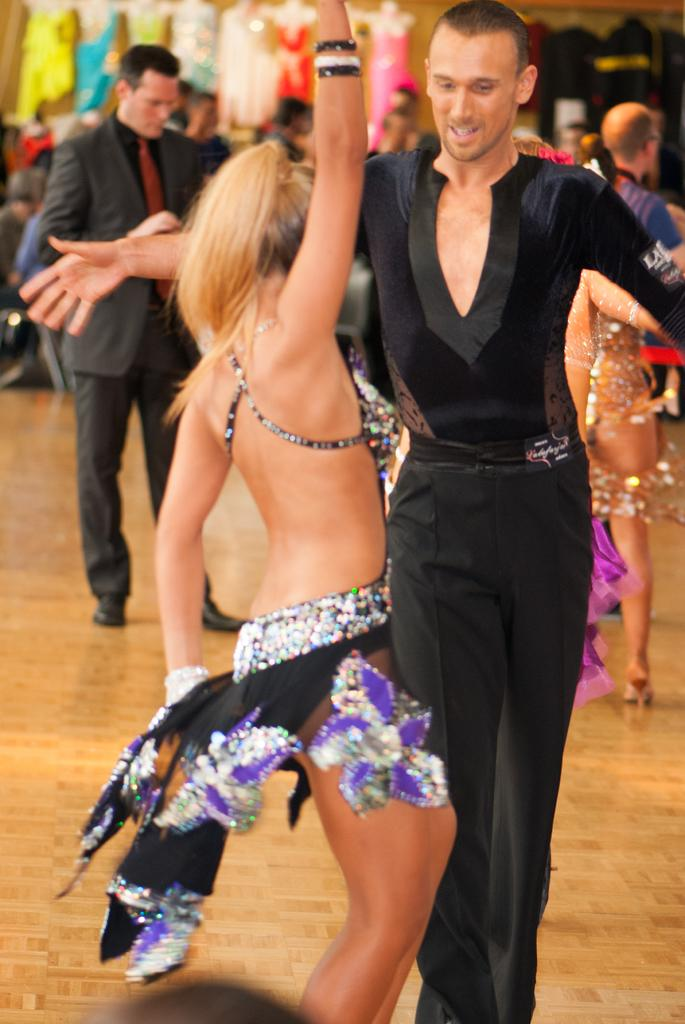Who are the two people in the image? There is a man and a woman in the image. What are they doing in the image? They are dancing on the floor. Can you describe the background of the image? There are people, a vehicle wheel, clothes, and other objects in the background of the image. What is located at the bottom of the image? There is an object at the bottom of the image. What type of kite is being flown by the man in the image? There is no kite present in the image; the man and woman are dancing on the floor. How does the crook affect the digestion of the woman in the image? There is no crook or mention of digestion in the image; it features a man and a woman dancing. 